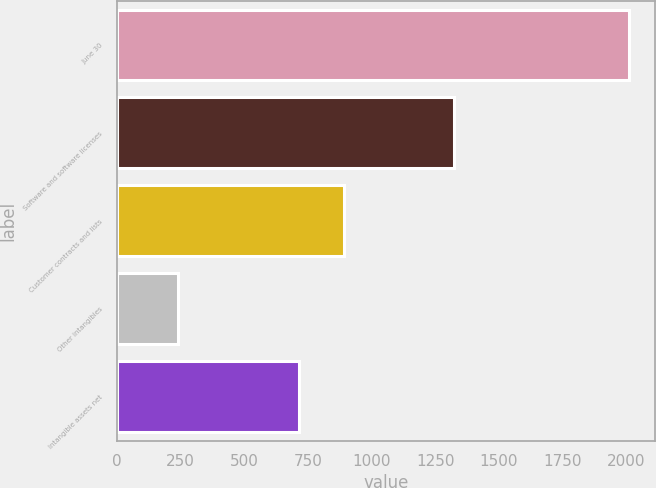Convert chart to OTSL. <chart><loc_0><loc_0><loc_500><loc_500><bar_chart><fcel>June 30<fcel>Software and software licenses<fcel>Customer contracts and lists<fcel>Other intangibles<fcel>Intangible assets net<nl><fcel>2011<fcel>1322.4<fcel>892.97<fcel>238.3<fcel>715.7<nl></chart> 